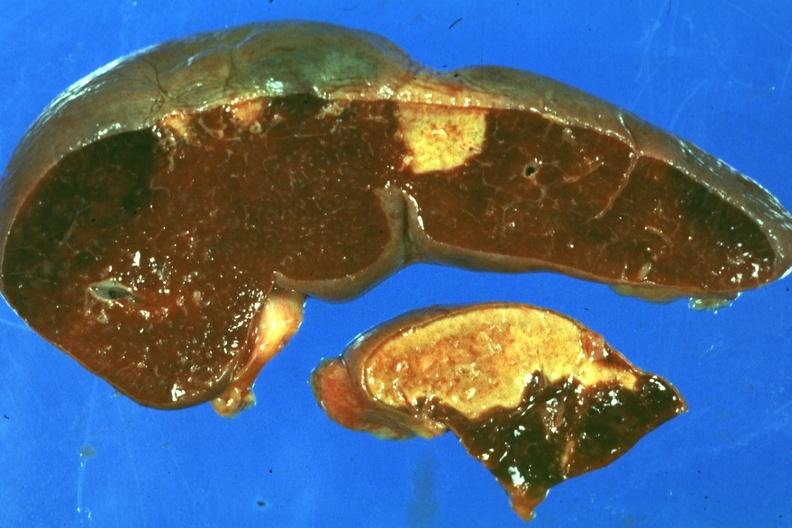s spleen present?
Answer the question using a single word or phrase. Yes 